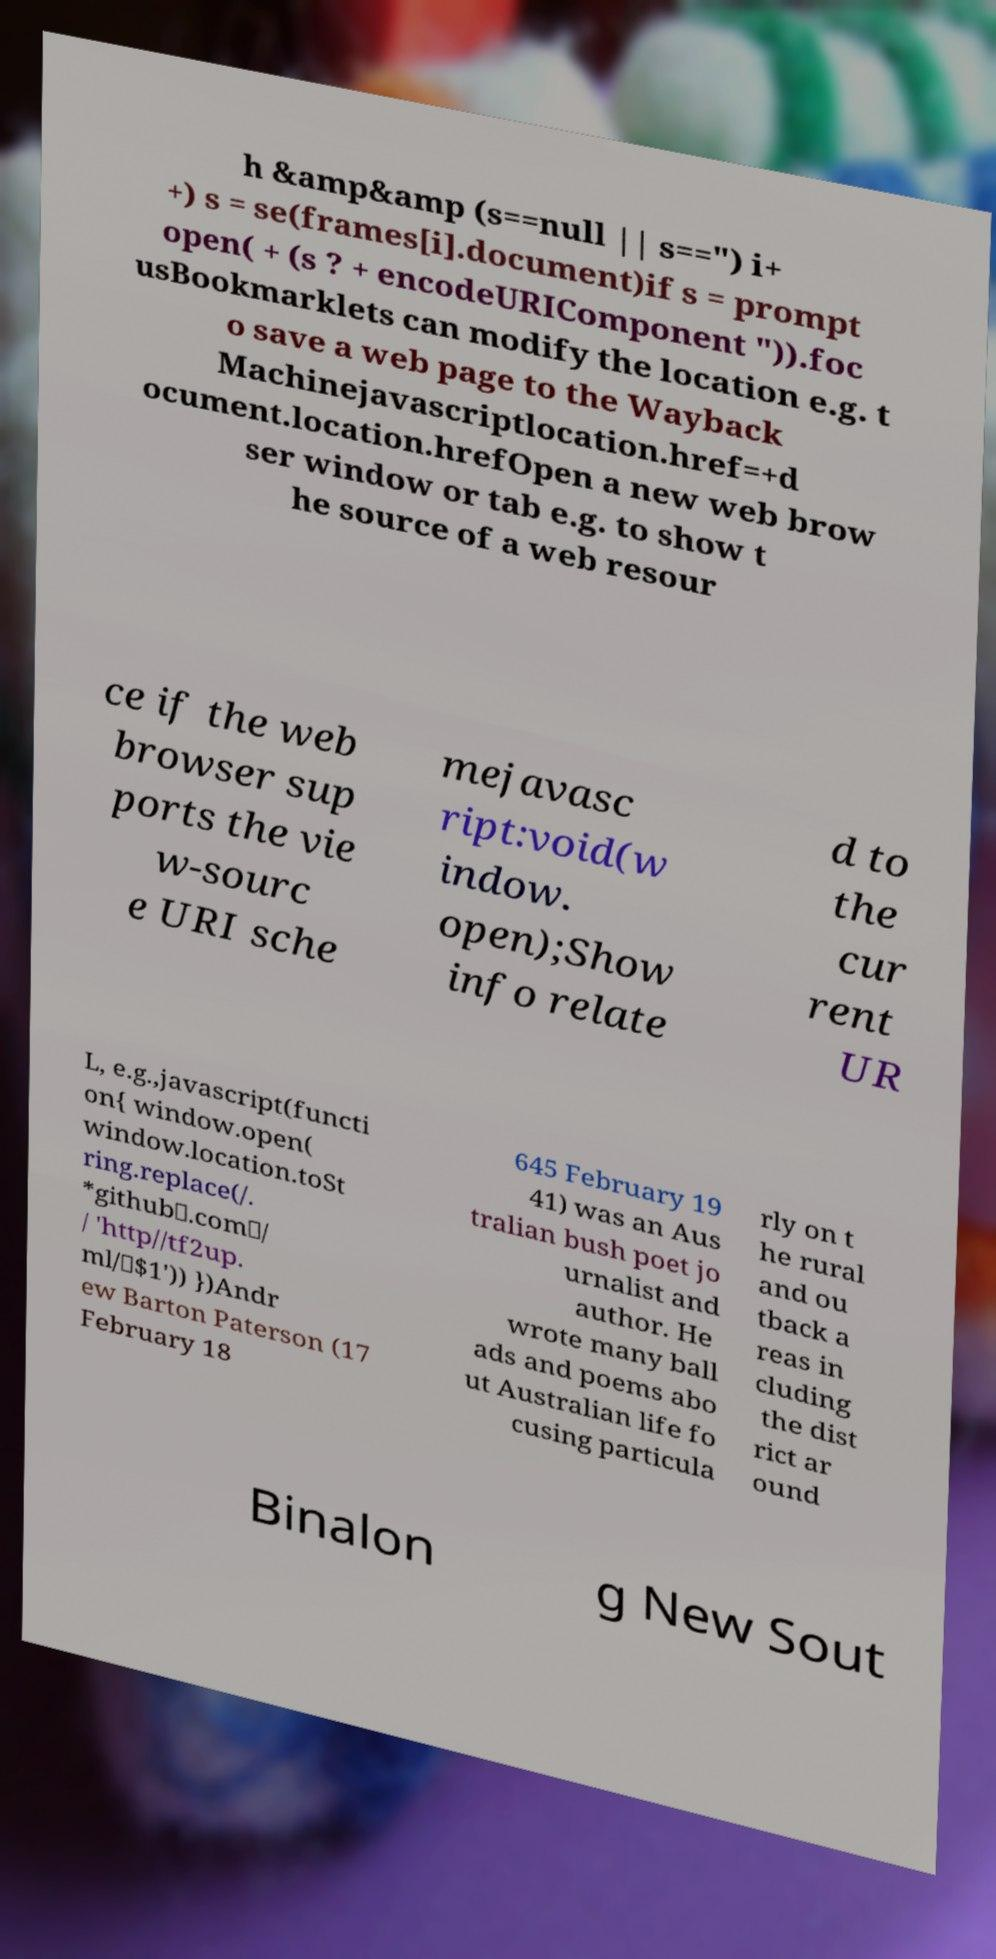I need the written content from this picture converted into text. Can you do that? h &amp&amp (s==null || s==") i+ +) s = se(frames[i].document)if s = prompt open( + (s ? + encodeURIComponent ")).foc usBookmarklets can modify the location e.g. t o save a web page to the Wayback Machinejavascriptlocation.href=+d ocument.location.hrefOpen a new web brow ser window or tab e.g. to show t he source of a web resour ce if the web browser sup ports the vie w-sourc e URI sche mejavasc ript:void(w indow. open);Show info relate d to the cur rent UR L, e.g.,javascript(functi on{ window.open( window.location.toSt ring.replace(/. *github\.com\/ / 'http//tf2up. ml/\$1')) })Andr ew Barton Paterson (17 February 18 645 February 19 41) was an Aus tralian bush poet jo urnalist and author. He wrote many ball ads and poems abo ut Australian life fo cusing particula rly on t he rural and ou tback a reas in cluding the dist rict ar ound Binalon g New Sout 